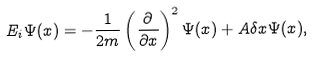Convert formula to latex. <formula><loc_0><loc_0><loc_500><loc_500>E _ { i } \Psi ( x ) = - \frac { 1 } { 2 m } \left ( \frac { \partial } { \partial x } \right ) ^ { 2 } \Psi ( x ) + A \delta x \Psi ( x ) ,</formula> 